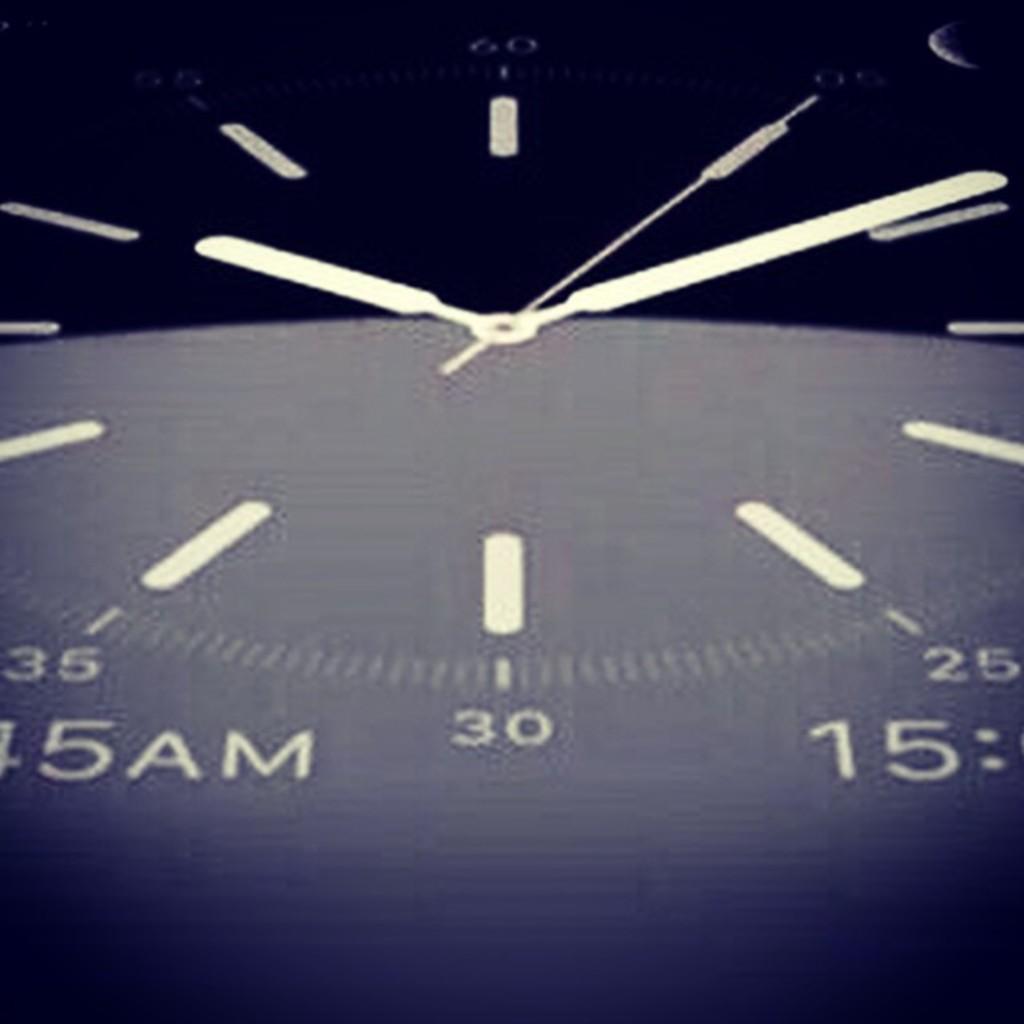What is the center number?
Provide a succinct answer. 30. What time is it/?
Make the answer very short. 10:09. 